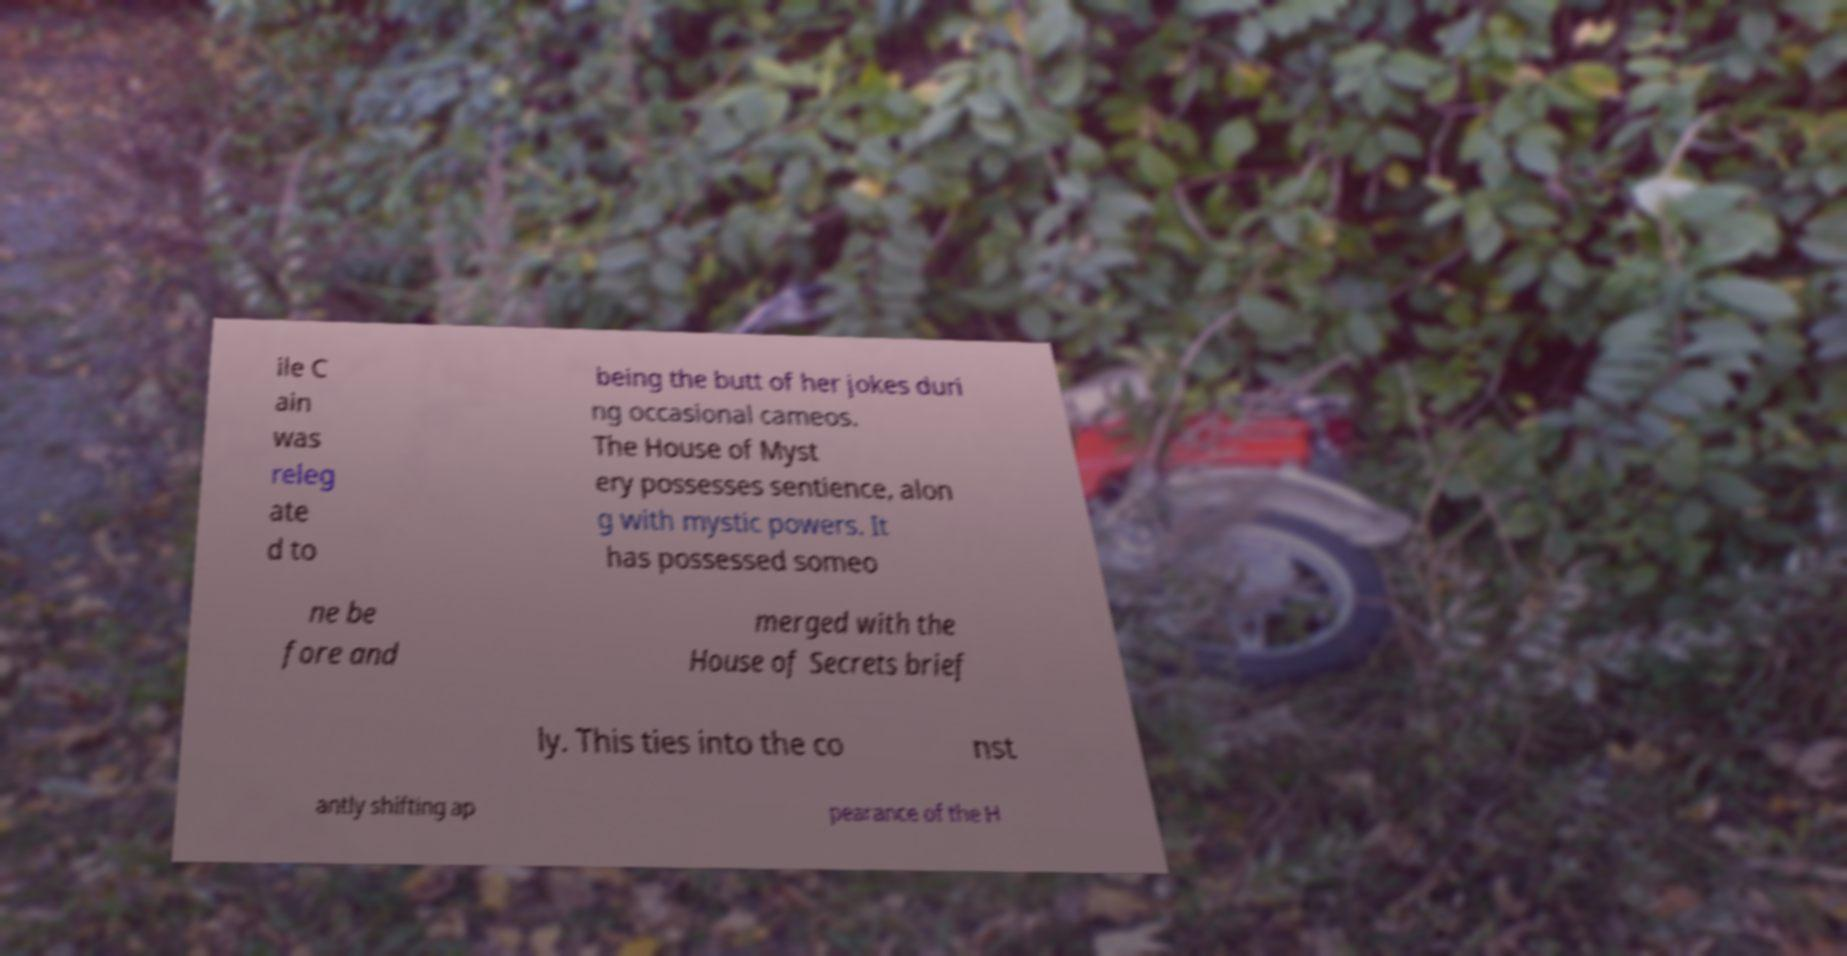For documentation purposes, I need the text within this image transcribed. Could you provide that? ile C ain was releg ate d to being the butt of her jokes duri ng occasional cameos. The House of Myst ery possesses sentience, alon g with mystic powers. It has possessed someo ne be fore and merged with the House of Secrets brief ly. This ties into the co nst antly shifting ap pearance of the H 